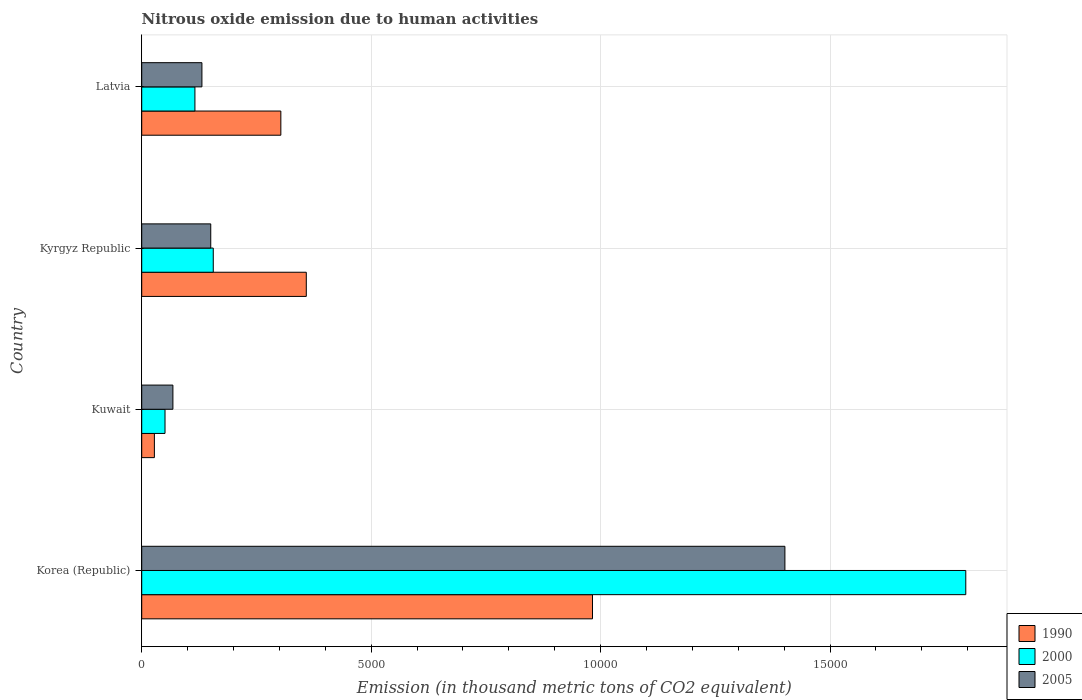How many different coloured bars are there?
Keep it short and to the point. 3. Are the number of bars per tick equal to the number of legend labels?
Make the answer very short. Yes. How many bars are there on the 2nd tick from the top?
Offer a very short reply. 3. How many bars are there on the 2nd tick from the bottom?
Provide a succinct answer. 3. What is the label of the 1st group of bars from the top?
Provide a succinct answer. Latvia. In how many cases, is the number of bars for a given country not equal to the number of legend labels?
Your answer should be very brief. 0. What is the amount of nitrous oxide emitted in 2000 in Korea (Republic)?
Offer a very short reply. 1.80e+04. Across all countries, what is the maximum amount of nitrous oxide emitted in 2005?
Offer a terse response. 1.40e+04. Across all countries, what is the minimum amount of nitrous oxide emitted in 2005?
Offer a very short reply. 679.5. In which country was the amount of nitrous oxide emitted in 1990 maximum?
Make the answer very short. Korea (Republic). In which country was the amount of nitrous oxide emitted in 2000 minimum?
Ensure brevity in your answer.  Kuwait. What is the total amount of nitrous oxide emitted in 2000 in the graph?
Keep it short and to the point. 2.12e+04. What is the difference between the amount of nitrous oxide emitted in 1990 in Korea (Republic) and that in Kyrgyz Republic?
Ensure brevity in your answer.  6236.9. What is the difference between the amount of nitrous oxide emitted in 2000 in Kuwait and the amount of nitrous oxide emitted in 1990 in Kyrgyz Republic?
Your response must be concise. -3078.9. What is the average amount of nitrous oxide emitted in 2005 per country?
Your response must be concise. 4378. What is the difference between the amount of nitrous oxide emitted in 1990 and amount of nitrous oxide emitted in 2000 in Kyrgyz Republic?
Offer a very short reply. 2027.4. What is the ratio of the amount of nitrous oxide emitted in 2005 in Kyrgyz Republic to that in Latvia?
Make the answer very short. 1.15. Is the amount of nitrous oxide emitted in 1990 in Kyrgyz Republic less than that in Latvia?
Your answer should be very brief. No. Is the difference between the amount of nitrous oxide emitted in 1990 in Kuwait and Latvia greater than the difference between the amount of nitrous oxide emitted in 2000 in Kuwait and Latvia?
Make the answer very short. No. What is the difference between the highest and the second highest amount of nitrous oxide emitted in 1990?
Your answer should be compact. 6236.9. What is the difference between the highest and the lowest amount of nitrous oxide emitted in 1990?
Give a very brief answer. 9547.3. What does the 2nd bar from the top in Kuwait represents?
Your answer should be very brief. 2000. How many countries are there in the graph?
Keep it short and to the point. 4. Are the values on the major ticks of X-axis written in scientific E-notation?
Your answer should be very brief. No. Does the graph contain any zero values?
Offer a terse response. No. Does the graph contain grids?
Your answer should be very brief. Yes. Where does the legend appear in the graph?
Give a very brief answer. Bottom right. How many legend labels are there?
Offer a terse response. 3. How are the legend labels stacked?
Your answer should be very brief. Vertical. What is the title of the graph?
Your response must be concise. Nitrous oxide emission due to human activities. What is the label or title of the X-axis?
Give a very brief answer. Emission (in thousand metric tons of CO2 equivalent). What is the Emission (in thousand metric tons of CO2 equivalent) of 1990 in Korea (Republic)?
Give a very brief answer. 9823.4. What is the Emission (in thousand metric tons of CO2 equivalent) in 2000 in Korea (Republic)?
Your answer should be compact. 1.80e+04. What is the Emission (in thousand metric tons of CO2 equivalent) of 2005 in Korea (Republic)?
Give a very brief answer. 1.40e+04. What is the Emission (in thousand metric tons of CO2 equivalent) of 1990 in Kuwait?
Give a very brief answer. 276.1. What is the Emission (in thousand metric tons of CO2 equivalent) in 2000 in Kuwait?
Ensure brevity in your answer.  507.6. What is the Emission (in thousand metric tons of CO2 equivalent) of 2005 in Kuwait?
Offer a very short reply. 679.5. What is the Emission (in thousand metric tons of CO2 equivalent) of 1990 in Kyrgyz Republic?
Your response must be concise. 3586.5. What is the Emission (in thousand metric tons of CO2 equivalent) of 2000 in Kyrgyz Republic?
Keep it short and to the point. 1559.1. What is the Emission (in thousand metric tons of CO2 equivalent) in 2005 in Kyrgyz Republic?
Provide a succinct answer. 1504.3. What is the Emission (in thousand metric tons of CO2 equivalent) of 1990 in Latvia?
Keep it short and to the point. 3031.8. What is the Emission (in thousand metric tons of CO2 equivalent) in 2000 in Latvia?
Keep it short and to the point. 1159.4. What is the Emission (in thousand metric tons of CO2 equivalent) in 2005 in Latvia?
Keep it short and to the point. 1311.8. Across all countries, what is the maximum Emission (in thousand metric tons of CO2 equivalent) of 1990?
Your response must be concise. 9823.4. Across all countries, what is the maximum Emission (in thousand metric tons of CO2 equivalent) of 2000?
Ensure brevity in your answer.  1.80e+04. Across all countries, what is the maximum Emission (in thousand metric tons of CO2 equivalent) of 2005?
Make the answer very short. 1.40e+04. Across all countries, what is the minimum Emission (in thousand metric tons of CO2 equivalent) in 1990?
Provide a short and direct response. 276.1. Across all countries, what is the minimum Emission (in thousand metric tons of CO2 equivalent) of 2000?
Provide a short and direct response. 507.6. Across all countries, what is the minimum Emission (in thousand metric tons of CO2 equivalent) in 2005?
Provide a short and direct response. 679.5. What is the total Emission (in thousand metric tons of CO2 equivalent) of 1990 in the graph?
Provide a succinct answer. 1.67e+04. What is the total Emission (in thousand metric tons of CO2 equivalent) of 2000 in the graph?
Offer a very short reply. 2.12e+04. What is the total Emission (in thousand metric tons of CO2 equivalent) in 2005 in the graph?
Provide a short and direct response. 1.75e+04. What is the difference between the Emission (in thousand metric tons of CO2 equivalent) in 1990 in Korea (Republic) and that in Kuwait?
Your response must be concise. 9547.3. What is the difference between the Emission (in thousand metric tons of CO2 equivalent) of 2000 in Korea (Republic) and that in Kuwait?
Give a very brief answer. 1.75e+04. What is the difference between the Emission (in thousand metric tons of CO2 equivalent) in 2005 in Korea (Republic) and that in Kuwait?
Provide a succinct answer. 1.33e+04. What is the difference between the Emission (in thousand metric tons of CO2 equivalent) of 1990 in Korea (Republic) and that in Kyrgyz Republic?
Offer a terse response. 6236.9. What is the difference between the Emission (in thousand metric tons of CO2 equivalent) of 2000 in Korea (Republic) and that in Kyrgyz Republic?
Make the answer very short. 1.64e+04. What is the difference between the Emission (in thousand metric tons of CO2 equivalent) of 2005 in Korea (Republic) and that in Kyrgyz Republic?
Offer a terse response. 1.25e+04. What is the difference between the Emission (in thousand metric tons of CO2 equivalent) of 1990 in Korea (Republic) and that in Latvia?
Keep it short and to the point. 6791.6. What is the difference between the Emission (in thousand metric tons of CO2 equivalent) of 2000 in Korea (Republic) and that in Latvia?
Give a very brief answer. 1.68e+04. What is the difference between the Emission (in thousand metric tons of CO2 equivalent) of 2005 in Korea (Republic) and that in Latvia?
Provide a short and direct response. 1.27e+04. What is the difference between the Emission (in thousand metric tons of CO2 equivalent) in 1990 in Kuwait and that in Kyrgyz Republic?
Ensure brevity in your answer.  -3310.4. What is the difference between the Emission (in thousand metric tons of CO2 equivalent) in 2000 in Kuwait and that in Kyrgyz Republic?
Your response must be concise. -1051.5. What is the difference between the Emission (in thousand metric tons of CO2 equivalent) of 2005 in Kuwait and that in Kyrgyz Republic?
Make the answer very short. -824.8. What is the difference between the Emission (in thousand metric tons of CO2 equivalent) of 1990 in Kuwait and that in Latvia?
Provide a short and direct response. -2755.7. What is the difference between the Emission (in thousand metric tons of CO2 equivalent) of 2000 in Kuwait and that in Latvia?
Make the answer very short. -651.8. What is the difference between the Emission (in thousand metric tons of CO2 equivalent) in 2005 in Kuwait and that in Latvia?
Make the answer very short. -632.3. What is the difference between the Emission (in thousand metric tons of CO2 equivalent) in 1990 in Kyrgyz Republic and that in Latvia?
Ensure brevity in your answer.  554.7. What is the difference between the Emission (in thousand metric tons of CO2 equivalent) in 2000 in Kyrgyz Republic and that in Latvia?
Ensure brevity in your answer.  399.7. What is the difference between the Emission (in thousand metric tons of CO2 equivalent) of 2005 in Kyrgyz Republic and that in Latvia?
Provide a succinct answer. 192.5. What is the difference between the Emission (in thousand metric tons of CO2 equivalent) in 1990 in Korea (Republic) and the Emission (in thousand metric tons of CO2 equivalent) in 2000 in Kuwait?
Your response must be concise. 9315.8. What is the difference between the Emission (in thousand metric tons of CO2 equivalent) of 1990 in Korea (Republic) and the Emission (in thousand metric tons of CO2 equivalent) of 2005 in Kuwait?
Keep it short and to the point. 9143.9. What is the difference between the Emission (in thousand metric tons of CO2 equivalent) in 2000 in Korea (Republic) and the Emission (in thousand metric tons of CO2 equivalent) in 2005 in Kuwait?
Your answer should be compact. 1.73e+04. What is the difference between the Emission (in thousand metric tons of CO2 equivalent) in 1990 in Korea (Republic) and the Emission (in thousand metric tons of CO2 equivalent) in 2000 in Kyrgyz Republic?
Offer a very short reply. 8264.3. What is the difference between the Emission (in thousand metric tons of CO2 equivalent) of 1990 in Korea (Republic) and the Emission (in thousand metric tons of CO2 equivalent) of 2005 in Kyrgyz Republic?
Your response must be concise. 8319.1. What is the difference between the Emission (in thousand metric tons of CO2 equivalent) of 2000 in Korea (Republic) and the Emission (in thousand metric tons of CO2 equivalent) of 2005 in Kyrgyz Republic?
Your answer should be compact. 1.65e+04. What is the difference between the Emission (in thousand metric tons of CO2 equivalent) in 1990 in Korea (Republic) and the Emission (in thousand metric tons of CO2 equivalent) in 2000 in Latvia?
Keep it short and to the point. 8664. What is the difference between the Emission (in thousand metric tons of CO2 equivalent) of 1990 in Korea (Republic) and the Emission (in thousand metric tons of CO2 equivalent) of 2005 in Latvia?
Provide a short and direct response. 8511.6. What is the difference between the Emission (in thousand metric tons of CO2 equivalent) in 2000 in Korea (Republic) and the Emission (in thousand metric tons of CO2 equivalent) in 2005 in Latvia?
Offer a terse response. 1.66e+04. What is the difference between the Emission (in thousand metric tons of CO2 equivalent) in 1990 in Kuwait and the Emission (in thousand metric tons of CO2 equivalent) in 2000 in Kyrgyz Republic?
Ensure brevity in your answer.  -1283. What is the difference between the Emission (in thousand metric tons of CO2 equivalent) in 1990 in Kuwait and the Emission (in thousand metric tons of CO2 equivalent) in 2005 in Kyrgyz Republic?
Your answer should be compact. -1228.2. What is the difference between the Emission (in thousand metric tons of CO2 equivalent) of 2000 in Kuwait and the Emission (in thousand metric tons of CO2 equivalent) of 2005 in Kyrgyz Republic?
Make the answer very short. -996.7. What is the difference between the Emission (in thousand metric tons of CO2 equivalent) of 1990 in Kuwait and the Emission (in thousand metric tons of CO2 equivalent) of 2000 in Latvia?
Offer a terse response. -883.3. What is the difference between the Emission (in thousand metric tons of CO2 equivalent) in 1990 in Kuwait and the Emission (in thousand metric tons of CO2 equivalent) in 2005 in Latvia?
Provide a short and direct response. -1035.7. What is the difference between the Emission (in thousand metric tons of CO2 equivalent) in 2000 in Kuwait and the Emission (in thousand metric tons of CO2 equivalent) in 2005 in Latvia?
Your answer should be very brief. -804.2. What is the difference between the Emission (in thousand metric tons of CO2 equivalent) in 1990 in Kyrgyz Republic and the Emission (in thousand metric tons of CO2 equivalent) in 2000 in Latvia?
Your answer should be compact. 2427.1. What is the difference between the Emission (in thousand metric tons of CO2 equivalent) of 1990 in Kyrgyz Republic and the Emission (in thousand metric tons of CO2 equivalent) of 2005 in Latvia?
Keep it short and to the point. 2274.7. What is the difference between the Emission (in thousand metric tons of CO2 equivalent) in 2000 in Kyrgyz Republic and the Emission (in thousand metric tons of CO2 equivalent) in 2005 in Latvia?
Your answer should be very brief. 247.3. What is the average Emission (in thousand metric tons of CO2 equivalent) of 1990 per country?
Offer a terse response. 4179.45. What is the average Emission (in thousand metric tons of CO2 equivalent) of 2000 per country?
Offer a terse response. 5296.05. What is the average Emission (in thousand metric tons of CO2 equivalent) in 2005 per country?
Keep it short and to the point. 4378. What is the difference between the Emission (in thousand metric tons of CO2 equivalent) of 1990 and Emission (in thousand metric tons of CO2 equivalent) of 2000 in Korea (Republic)?
Provide a short and direct response. -8134.7. What is the difference between the Emission (in thousand metric tons of CO2 equivalent) of 1990 and Emission (in thousand metric tons of CO2 equivalent) of 2005 in Korea (Republic)?
Your answer should be very brief. -4193. What is the difference between the Emission (in thousand metric tons of CO2 equivalent) of 2000 and Emission (in thousand metric tons of CO2 equivalent) of 2005 in Korea (Republic)?
Your response must be concise. 3941.7. What is the difference between the Emission (in thousand metric tons of CO2 equivalent) of 1990 and Emission (in thousand metric tons of CO2 equivalent) of 2000 in Kuwait?
Your answer should be compact. -231.5. What is the difference between the Emission (in thousand metric tons of CO2 equivalent) of 1990 and Emission (in thousand metric tons of CO2 equivalent) of 2005 in Kuwait?
Provide a short and direct response. -403.4. What is the difference between the Emission (in thousand metric tons of CO2 equivalent) of 2000 and Emission (in thousand metric tons of CO2 equivalent) of 2005 in Kuwait?
Ensure brevity in your answer.  -171.9. What is the difference between the Emission (in thousand metric tons of CO2 equivalent) of 1990 and Emission (in thousand metric tons of CO2 equivalent) of 2000 in Kyrgyz Republic?
Provide a short and direct response. 2027.4. What is the difference between the Emission (in thousand metric tons of CO2 equivalent) of 1990 and Emission (in thousand metric tons of CO2 equivalent) of 2005 in Kyrgyz Republic?
Provide a short and direct response. 2082.2. What is the difference between the Emission (in thousand metric tons of CO2 equivalent) in 2000 and Emission (in thousand metric tons of CO2 equivalent) in 2005 in Kyrgyz Republic?
Ensure brevity in your answer.  54.8. What is the difference between the Emission (in thousand metric tons of CO2 equivalent) of 1990 and Emission (in thousand metric tons of CO2 equivalent) of 2000 in Latvia?
Provide a short and direct response. 1872.4. What is the difference between the Emission (in thousand metric tons of CO2 equivalent) of 1990 and Emission (in thousand metric tons of CO2 equivalent) of 2005 in Latvia?
Give a very brief answer. 1720. What is the difference between the Emission (in thousand metric tons of CO2 equivalent) of 2000 and Emission (in thousand metric tons of CO2 equivalent) of 2005 in Latvia?
Offer a terse response. -152.4. What is the ratio of the Emission (in thousand metric tons of CO2 equivalent) of 1990 in Korea (Republic) to that in Kuwait?
Ensure brevity in your answer.  35.58. What is the ratio of the Emission (in thousand metric tons of CO2 equivalent) of 2000 in Korea (Republic) to that in Kuwait?
Give a very brief answer. 35.38. What is the ratio of the Emission (in thousand metric tons of CO2 equivalent) of 2005 in Korea (Republic) to that in Kuwait?
Your response must be concise. 20.63. What is the ratio of the Emission (in thousand metric tons of CO2 equivalent) of 1990 in Korea (Republic) to that in Kyrgyz Republic?
Make the answer very short. 2.74. What is the ratio of the Emission (in thousand metric tons of CO2 equivalent) of 2000 in Korea (Republic) to that in Kyrgyz Republic?
Your answer should be very brief. 11.52. What is the ratio of the Emission (in thousand metric tons of CO2 equivalent) in 2005 in Korea (Republic) to that in Kyrgyz Republic?
Your response must be concise. 9.32. What is the ratio of the Emission (in thousand metric tons of CO2 equivalent) in 1990 in Korea (Republic) to that in Latvia?
Make the answer very short. 3.24. What is the ratio of the Emission (in thousand metric tons of CO2 equivalent) in 2000 in Korea (Republic) to that in Latvia?
Make the answer very short. 15.49. What is the ratio of the Emission (in thousand metric tons of CO2 equivalent) of 2005 in Korea (Republic) to that in Latvia?
Offer a terse response. 10.68. What is the ratio of the Emission (in thousand metric tons of CO2 equivalent) of 1990 in Kuwait to that in Kyrgyz Republic?
Give a very brief answer. 0.08. What is the ratio of the Emission (in thousand metric tons of CO2 equivalent) of 2000 in Kuwait to that in Kyrgyz Republic?
Offer a very short reply. 0.33. What is the ratio of the Emission (in thousand metric tons of CO2 equivalent) in 2005 in Kuwait to that in Kyrgyz Republic?
Provide a succinct answer. 0.45. What is the ratio of the Emission (in thousand metric tons of CO2 equivalent) of 1990 in Kuwait to that in Latvia?
Your answer should be compact. 0.09. What is the ratio of the Emission (in thousand metric tons of CO2 equivalent) in 2000 in Kuwait to that in Latvia?
Offer a very short reply. 0.44. What is the ratio of the Emission (in thousand metric tons of CO2 equivalent) in 2005 in Kuwait to that in Latvia?
Provide a short and direct response. 0.52. What is the ratio of the Emission (in thousand metric tons of CO2 equivalent) in 1990 in Kyrgyz Republic to that in Latvia?
Give a very brief answer. 1.18. What is the ratio of the Emission (in thousand metric tons of CO2 equivalent) in 2000 in Kyrgyz Republic to that in Latvia?
Your answer should be very brief. 1.34. What is the ratio of the Emission (in thousand metric tons of CO2 equivalent) of 2005 in Kyrgyz Republic to that in Latvia?
Offer a terse response. 1.15. What is the difference between the highest and the second highest Emission (in thousand metric tons of CO2 equivalent) of 1990?
Make the answer very short. 6236.9. What is the difference between the highest and the second highest Emission (in thousand metric tons of CO2 equivalent) of 2000?
Your answer should be very brief. 1.64e+04. What is the difference between the highest and the second highest Emission (in thousand metric tons of CO2 equivalent) in 2005?
Provide a short and direct response. 1.25e+04. What is the difference between the highest and the lowest Emission (in thousand metric tons of CO2 equivalent) in 1990?
Ensure brevity in your answer.  9547.3. What is the difference between the highest and the lowest Emission (in thousand metric tons of CO2 equivalent) in 2000?
Offer a very short reply. 1.75e+04. What is the difference between the highest and the lowest Emission (in thousand metric tons of CO2 equivalent) of 2005?
Provide a short and direct response. 1.33e+04. 